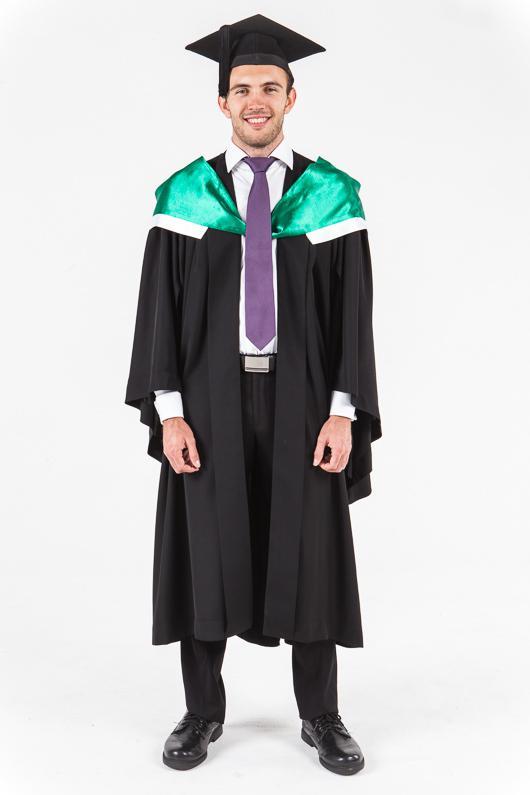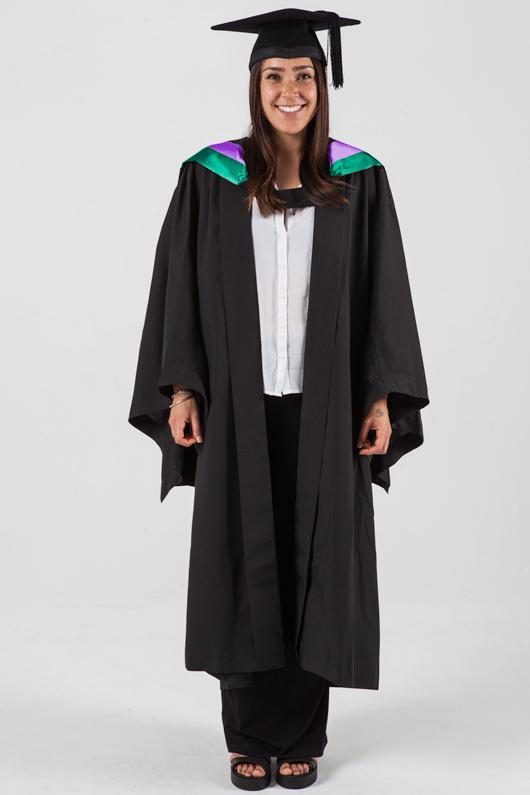The first image is the image on the left, the second image is the image on the right. Considering the images on both sides, is "There is a woman in the image on the right." valid? Answer yes or no. Yes. 